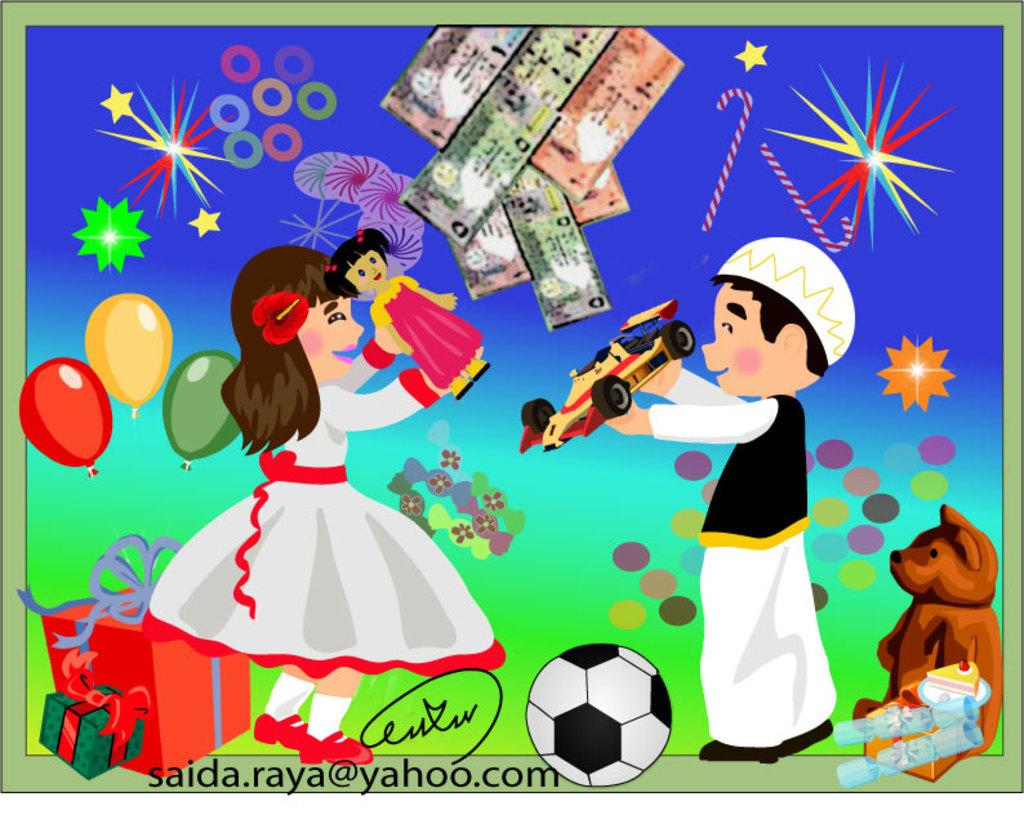What is depicted on the poster in the image? The poster features two people, balloons, and gifts. What else can be seen on the poster besides the images? There is text on the poster. What is the opinion of the person in jail on the poster? There is no person in jail depicted on the poster, and therefore no opinion can be attributed to them. 